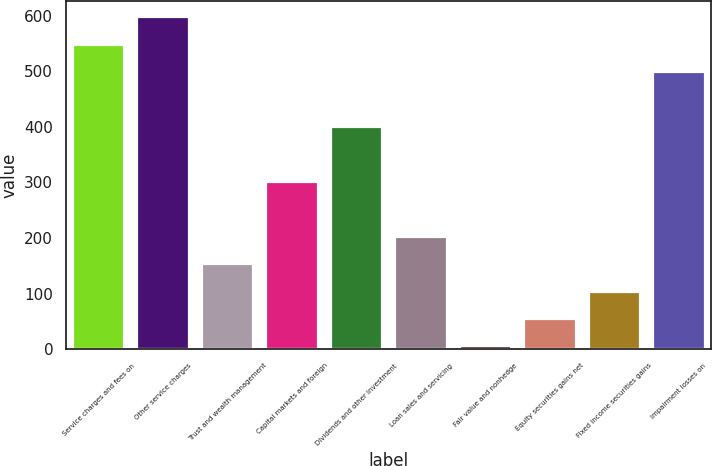Convert chart. <chart><loc_0><loc_0><loc_500><loc_500><bar_chart><fcel>Service charges and fees on<fcel>Other service charges<fcel>Trust and wealth management<fcel>Capital markets and foreign<fcel>Dividends and other investment<fcel>Loan sales and servicing<fcel>Fair value and nonhedge<fcel>Equity securities gains net<fcel>Fixed income securities gains<fcel>Impairment losses on<nl><fcel>547.52<fcel>596.84<fcel>152.96<fcel>300.92<fcel>399.56<fcel>202.28<fcel>5<fcel>54.32<fcel>103.64<fcel>498.2<nl></chart> 